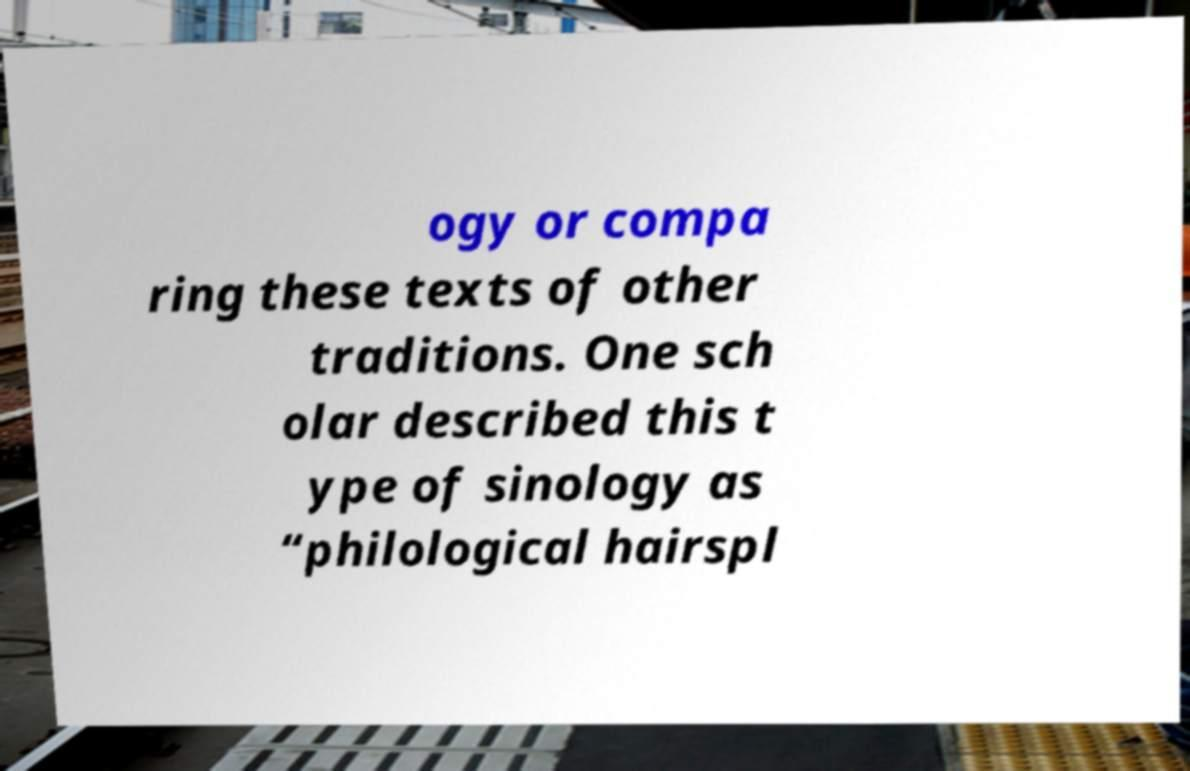Please read and relay the text visible in this image. What does it say? ogy or compa ring these texts of other traditions. One sch olar described this t ype of sinology as “philological hairspl 